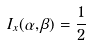<formula> <loc_0><loc_0><loc_500><loc_500>I _ { x } ( \alpha , \beta ) = { \frac { 1 } { 2 } }</formula> 